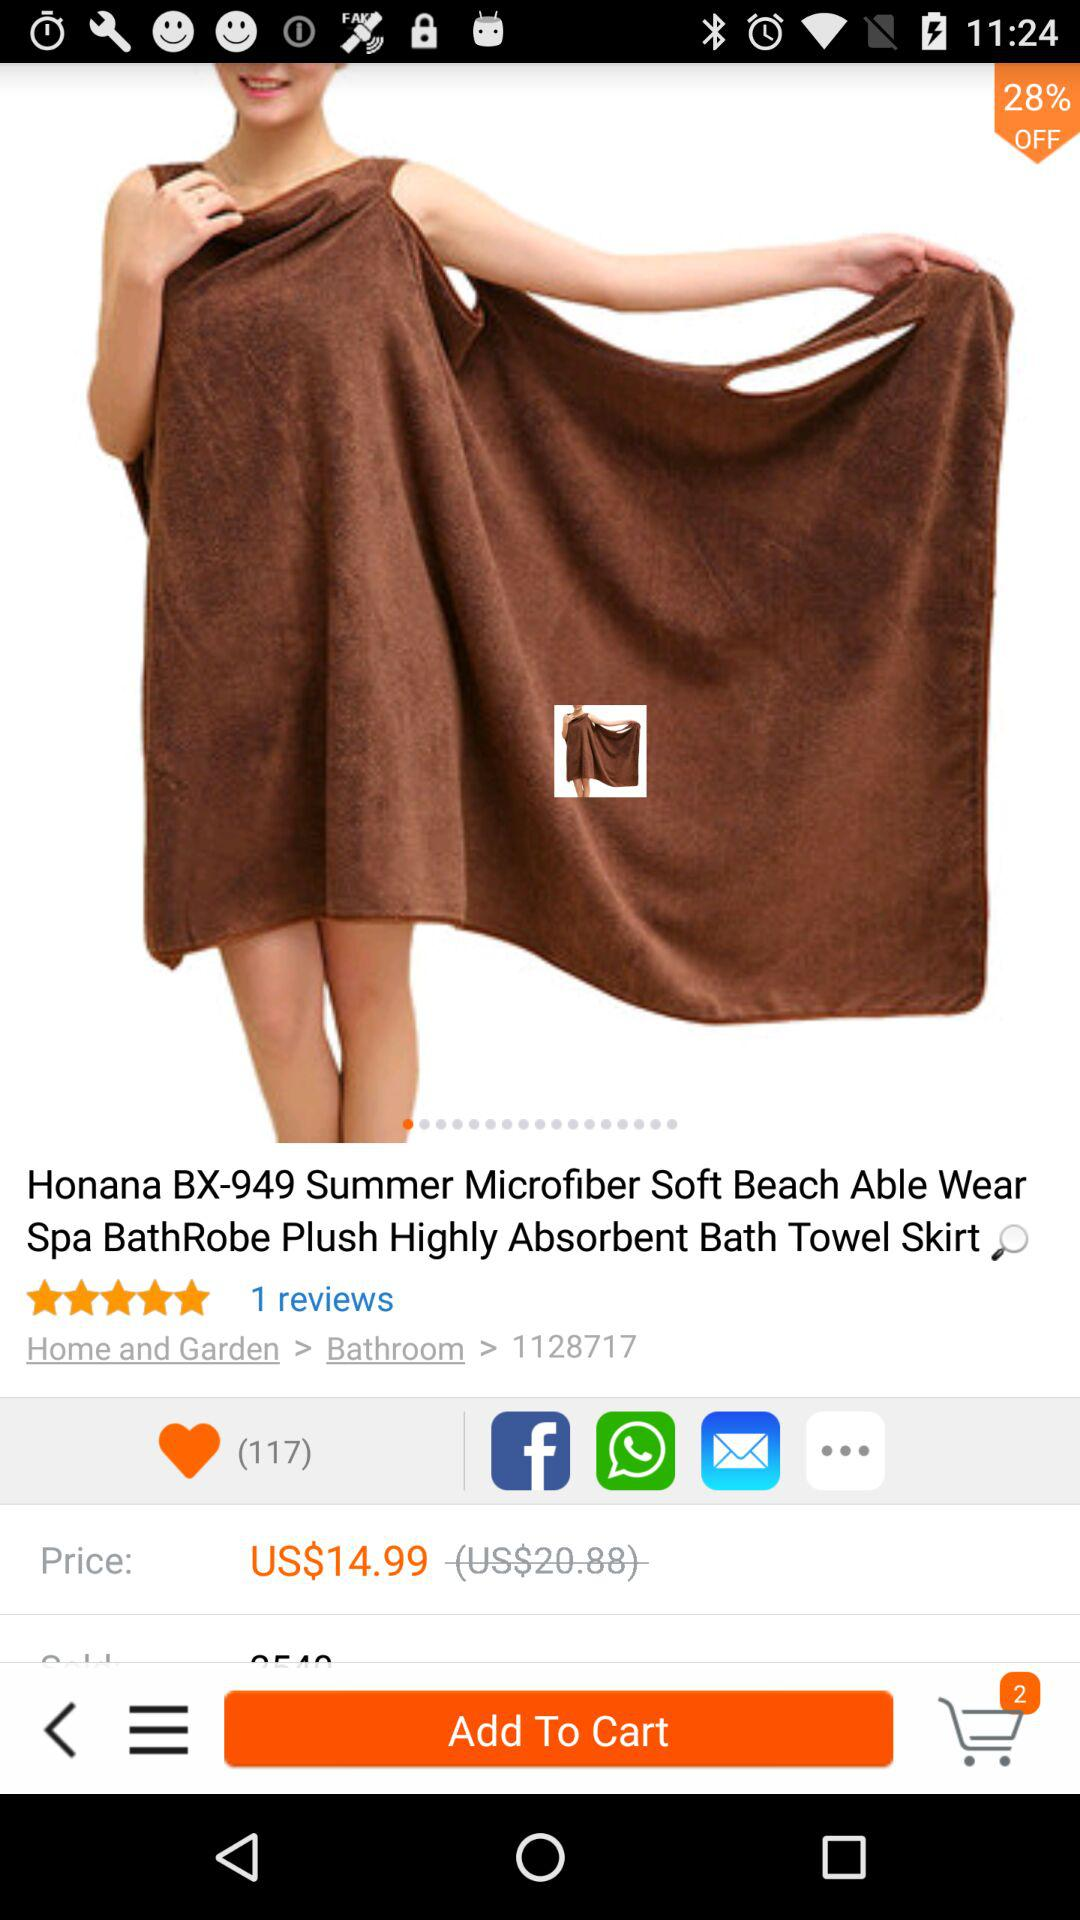What is the currency of price? The price is in US dollars. 